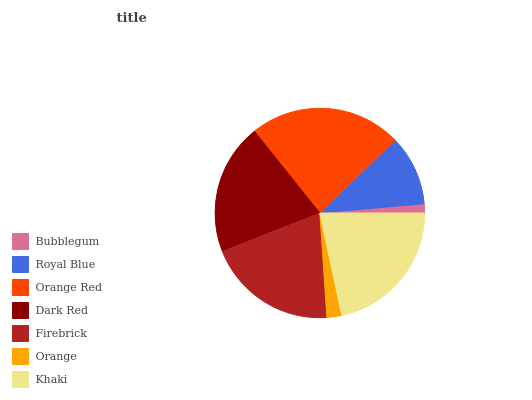Is Bubblegum the minimum?
Answer yes or no. Yes. Is Orange Red the maximum?
Answer yes or no. Yes. Is Royal Blue the minimum?
Answer yes or no. No. Is Royal Blue the maximum?
Answer yes or no. No. Is Royal Blue greater than Bubblegum?
Answer yes or no. Yes. Is Bubblegum less than Royal Blue?
Answer yes or no. Yes. Is Bubblegum greater than Royal Blue?
Answer yes or no. No. Is Royal Blue less than Bubblegum?
Answer yes or no. No. Is Firebrick the high median?
Answer yes or no. Yes. Is Firebrick the low median?
Answer yes or no. Yes. Is Royal Blue the high median?
Answer yes or no. No. Is Orange Red the low median?
Answer yes or no. No. 